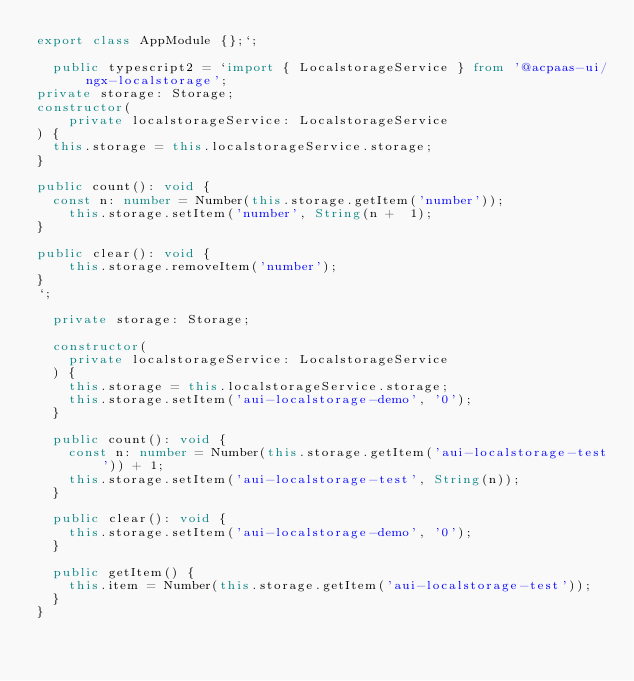<code> <loc_0><loc_0><loc_500><loc_500><_TypeScript_>export class AppModule {};`;

  public typescript2 = `import { LocalstorageService } from '@acpaas-ui/ngx-localstorage';
private storage: Storage;
constructor(
	private localstorageService: LocalstorageService
) {
  this.storage = this.localstorageService.storage;
}

public count(): void {
  const n: number = Number(this.storage.getItem('number'));
	this.storage.setItem('number', String(n +  1);
}

public clear(): void {
	this.storage.removeItem('number');
}
`;

  private storage: Storage;

  constructor(
    private localstorageService: LocalstorageService
  ) {
    this.storage = this.localstorageService.storage;
    this.storage.setItem('aui-localstorage-demo', '0');
  }

  public count(): void {
    const n: number = Number(this.storage.getItem('aui-localstorage-test')) + 1;
    this.storage.setItem('aui-localstorage-test', String(n));
  }

  public clear(): void {
    this.storage.setItem('aui-localstorage-demo', '0');
  }

  public getItem() {
    this.item = Number(this.storage.getItem('aui-localstorage-test'));
  }
}
</code> 